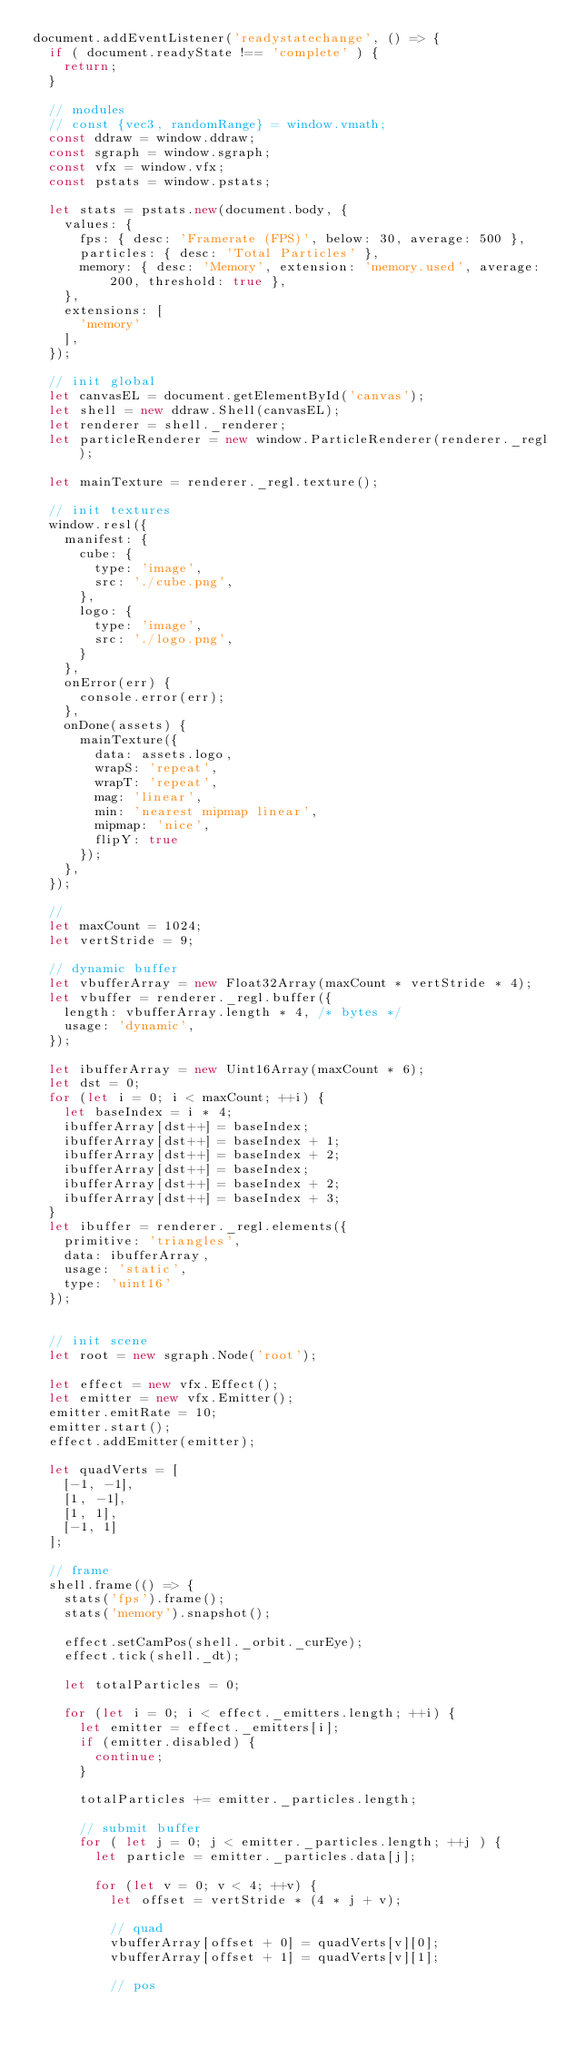Convert code to text. <code><loc_0><loc_0><loc_500><loc_500><_JavaScript_>document.addEventListener('readystatechange', () => {
  if ( document.readyState !== 'complete' ) {
    return;
  }

  // modules
  // const {vec3, randomRange} = window.vmath;
  const ddraw = window.ddraw;
  const sgraph = window.sgraph;
  const vfx = window.vfx;
  const pstats = window.pstats;

  let stats = pstats.new(document.body, {
    values: {
      fps: { desc: 'Framerate (FPS)', below: 30, average: 500 },
      particles: { desc: 'Total Particles' },
      memory: { desc: 'Memory', extension: 'memory.used', average: 200, threshold: true },
    },
    extensions: [
      'memory'
    ],
  });

  // init global
  let canvasEL = document.getElementById('canvas');
  let shell = new ddraw.Shell(canvasEL);
  let renderer = shell._renderer;
  let particleRenderer = new window.ParticleRenderer(renderer._regl);

  let mainTexture = renderer._regl.texture();

  // init textures
  window.resl({
    manifest: {
      cube: {
        type: 'image',
        src: './cube.png',
      },
      logo: {
        type: 'image',
        src: './logo.png',
      }
    },
    onError(err) {
      console.error(err);
    },
    onDone(assets) {
      mainTexture({
        data: assets.logo,
        wrapS: 'repeat',
        wrapT: 'repeat',
        mag: 'linear',
        min: 'nearest mipmap linear',
        mipmap: 'nice',
        flipY: true
      });
    },
  });

  //
  let maxCount = 1024;
  let vertStride = 9;

  // dynamic buffer
  let vbufferArray = new Float32Array(maxCount * vertStride * 4);
  let vbuffer = renderer._regl.buffer({
    length: vbufferArray.length * 4, /* bytes */
    usage: 'dynamic',
  });

  let ibufferArray = new Uint16Array(maxCount * 6);
  let dst = 0;
  for (let i = 0; i < maxCount; ++i) {
    let baseIndex = i * 4;
    ibufferArray[dst++] = baseIndex;
    ibufferArray[dst++] = baseIndex + 1;
    ibufferArray[dst++] = baseIndex + 2;
    ibufferArray[dst++] = baseIndex;
    ibufferArray[dst++] = baseIndex + 2;
    ibufferArray[dst++] = baseIndex + 3;
  }
  let ibuffer = renderer._regl.elements({
    primitive: 'triangles',
    data: ibufferArray,
    usage: 'static',
    type: 'uint16'
  });


  // init scene
  let root = new sgraph.Node('root');

  let effect = new vfx.Effect();
  let emitter = new vfx.Emitter();
  emitter.emitRate = 10;
  emitter.start();
  effect.addEmitter(emitter);

  let quadVerts = [
    [-1, -1],
    [1, -1],
    [1, 1],
    [-1, 1]
  ];

  // frame
  shell.frame(() => {
    stats('fps').frame();
    stats('memory').snapshot();

    effect.setCamPos(shell._orbit._curEye);
    effect.tick(shell._dt);

    let totalParticles = 0;

    for (let i = 0; i < effect._emitters.length; ++i) {
      let emitter = effect._emitters[i];
      if (emitter.disabled) {
        continue;
      }

      totalParticles += emitter._particles.length;

      // submit buffer
      for ( let j = 0; j < emitter._particles.length; ++j ) {
        let particle = emitter._particles.data[j];

        for (let v = 0; v < 4; ++v) {
          let offset = vertStride * (4 * j + v);

          // quad
          vbufferArray[offset + 0] = quadVerts[v][0];
          vbufferArray[offset + 1] = quadVerts[v][1];

          // pos</code> 